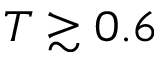Convert formula to latex. <formula><loc_0><loc_0><loc_500><loc_500>T \gtrsim 0 . 6</formula> 